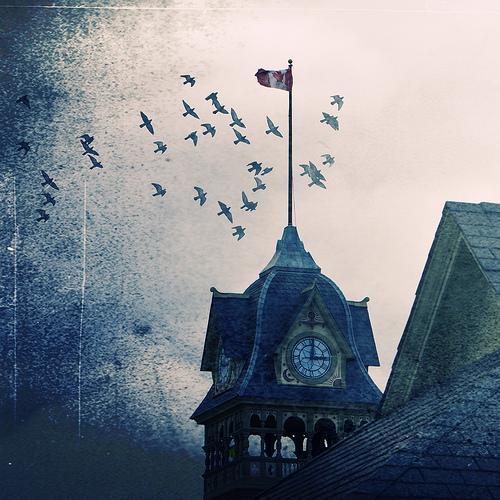How many flags are there?
Give a very brief answer. 1. How many clocks are visible?
Give a very brief answer. 2. 